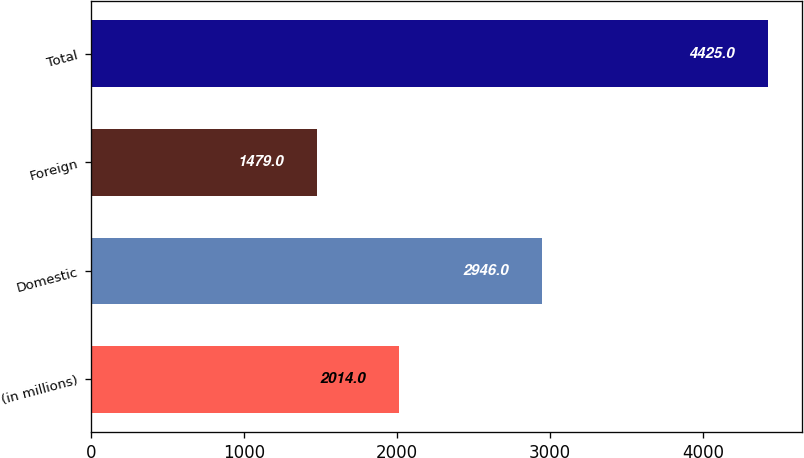Convert chart. <chart><loc_0><loc_0><loc_500><loc_500><bar_chart><fcel>(in millions)<fcel>Domestic<fcel>Foreign<fcel>Total<nl><fcel>2014<fcel>2946<fcel>1479<fcel>4425<nl></chart> 